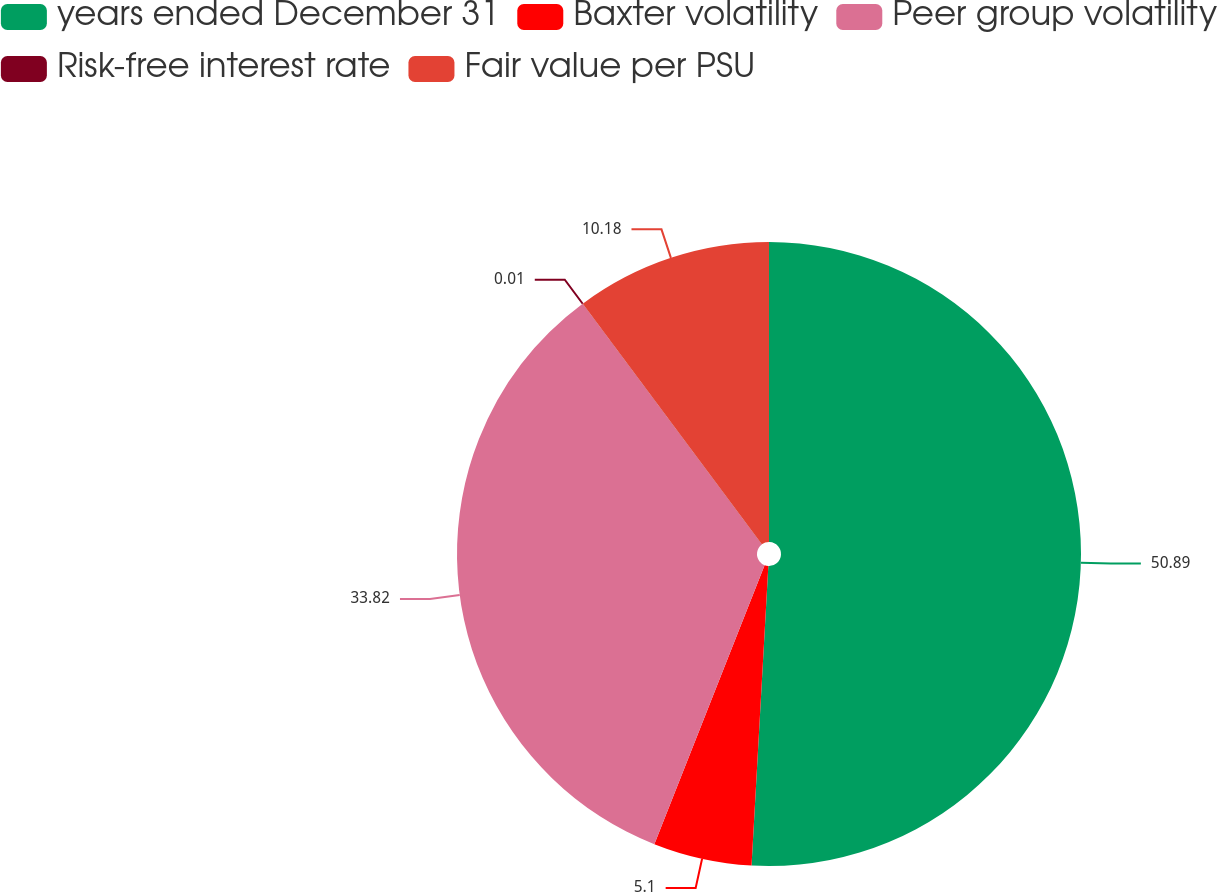<chart> <loc_0><loc_0><loc_500><loc_500><pie_chart><fcel>years ended December 31<fcel>Baxter volatility<fcel>Peer group volatility<fcel>Risk-free interest rate<fcel>Fair value per PSU<nl><fcel>50.89%<fcel>5.1%<fcel>33.82%<fcel>0.01%<fcel>10.18%<nl></chart> 